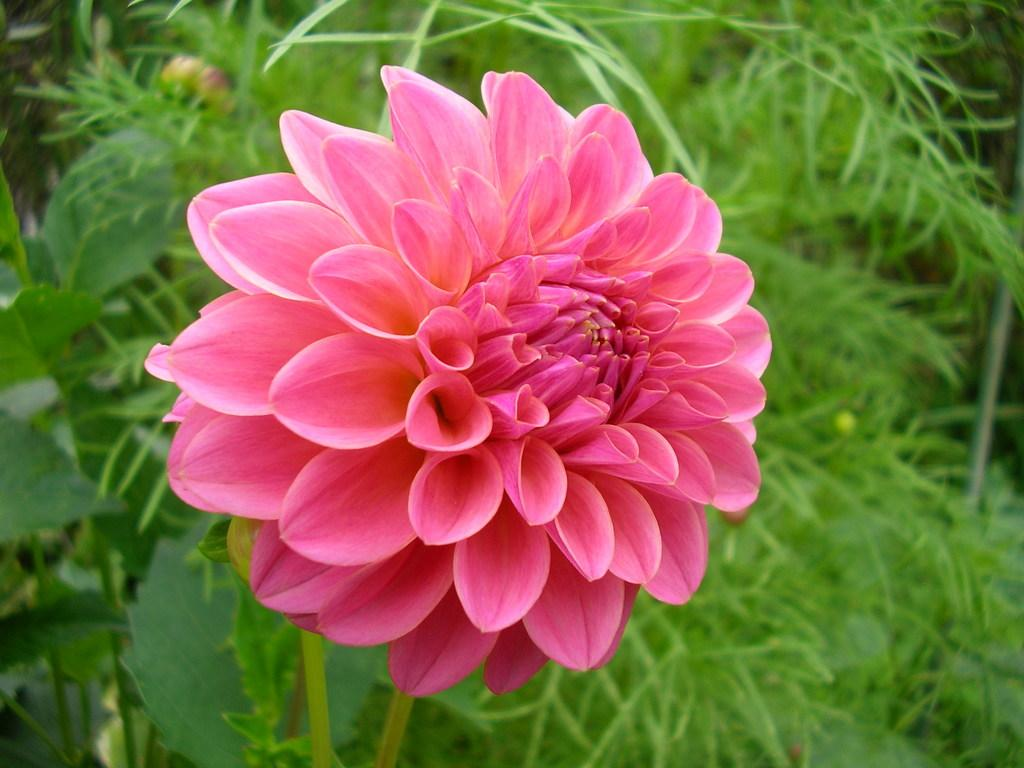What type of plant is featured in the image? The image features a plant with a flower. What color is the flower on the plant? The flower is pink. What type of copper material is used to make the camp on the slope in the image? There is no copper, camp, or slope present in the image; it features a flower on a plant. 